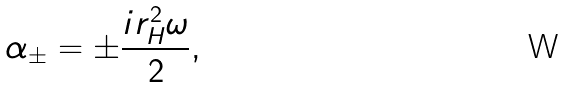<formula> <loc_0><loc_0><loc_500><loc_500>\alpha _ { \pm } = \pm \frac { i r _ { H } ^ { 2 } \omega } { 2 } ,</formula> 